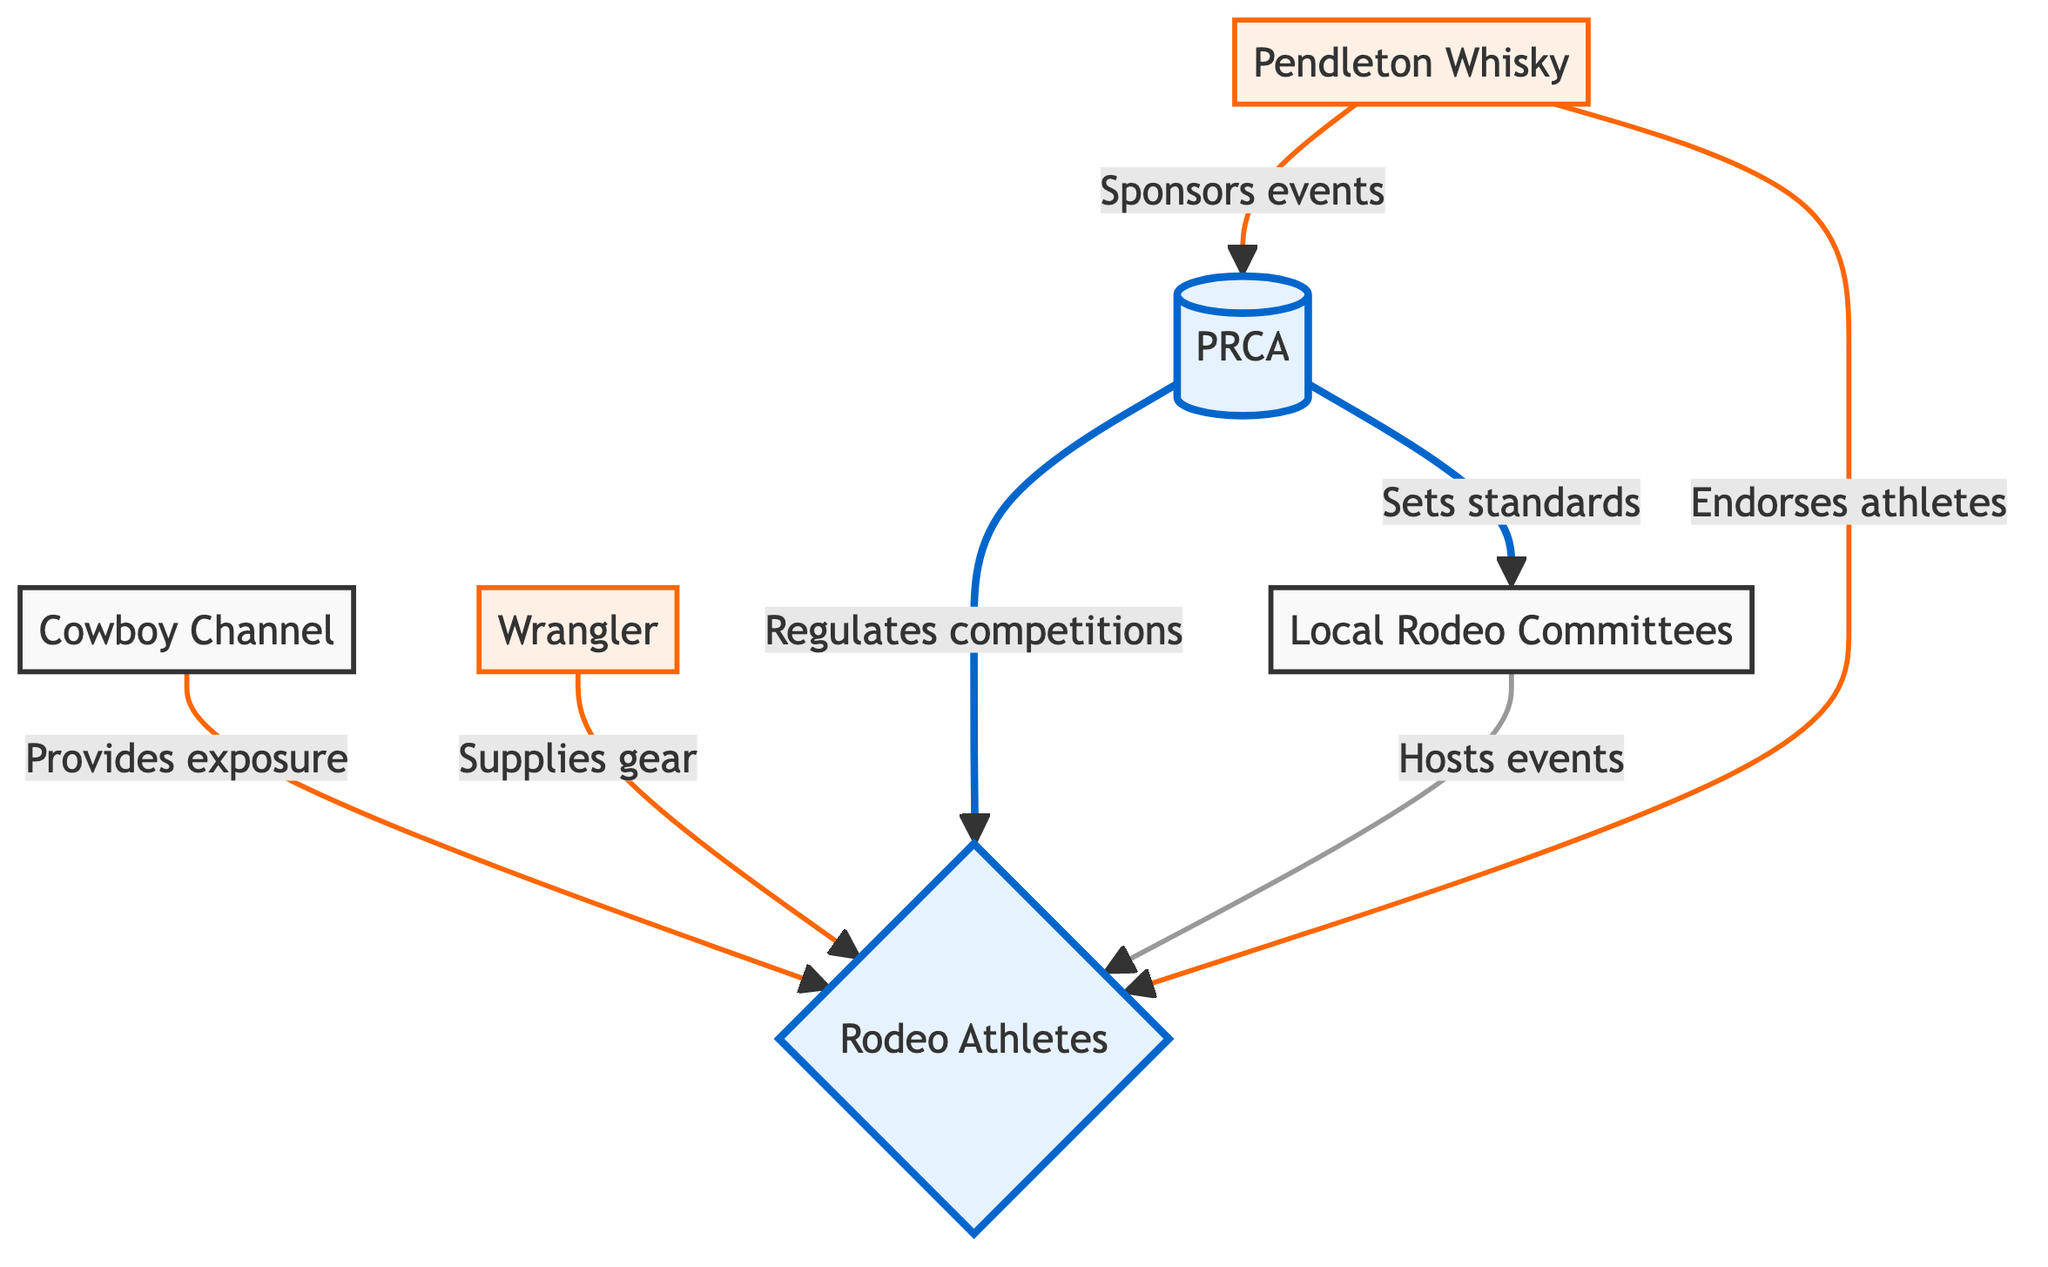What organization regulates competitions in the rodeo industry? The diagram indicates that the "PRCA" regulates competitions, as it has a direct relationship with the node "Rodeo Athletes" that states "Regulates competitions".
Answer: PRCA Which organization provides exposure to rodeo athletes? The "Cowboy Channel" is the entity that provides exposure, linked directly to "Rodeo Athletes" with the label "Provides exposure".
Answer: Cowboy Channel How many major stakeholders are represented in the diagram? The major stakeholders identified in the diagram include "PRCA", "Rodeo Athletes", and "Local Rodeo Committees". Counting these entities gives a total of three major stakeholders.
Answer: 3 What does "Pendleton Whisky" do in relation to events? According to the diagram, "Pendleton Whisky" sponsors events, as indicated by the connection to "PRCA" with the label "Sponsors events".
Answer: Sponsors events Which entity endorses rodeo athletes? The diagram shows that "Pendleton Whisky" endorses athletes, as there is a direct link to "Rodeo Athletes" stating "Endorses athletes".
Answer: Pendleton Whisky How many sponsorships are mentioned in the diagram? The diagram outlines two sponsorships: "Wrangler" supplies gear and "Pendleton Whisky" sponsors events and endorses athletes. This totals three identified sponsorships.
Answer: 3 Which stakeholder hosts events in the rodeo industry? The "Local Rodeo Committees" are depicted as hosting events, based on the connecting line indicating "Hosts events".
Answer: Local Rodeo Committees What is the relationship between PRCA and Local Rodeo Committees? The diagram specifies that the PRCA sets standards for Local Rodeo Committees, represented by the connection labeled "Sets standards".
Answer: Sets standards What type of diagram is used to represent the dynamics in the rodeo industry? This diagram is categorized as a "Textbook Diagram", as it visually organizes the relationships and influences of various stakeholders within the rodeo industry.
Answer: Textbook Diagram 